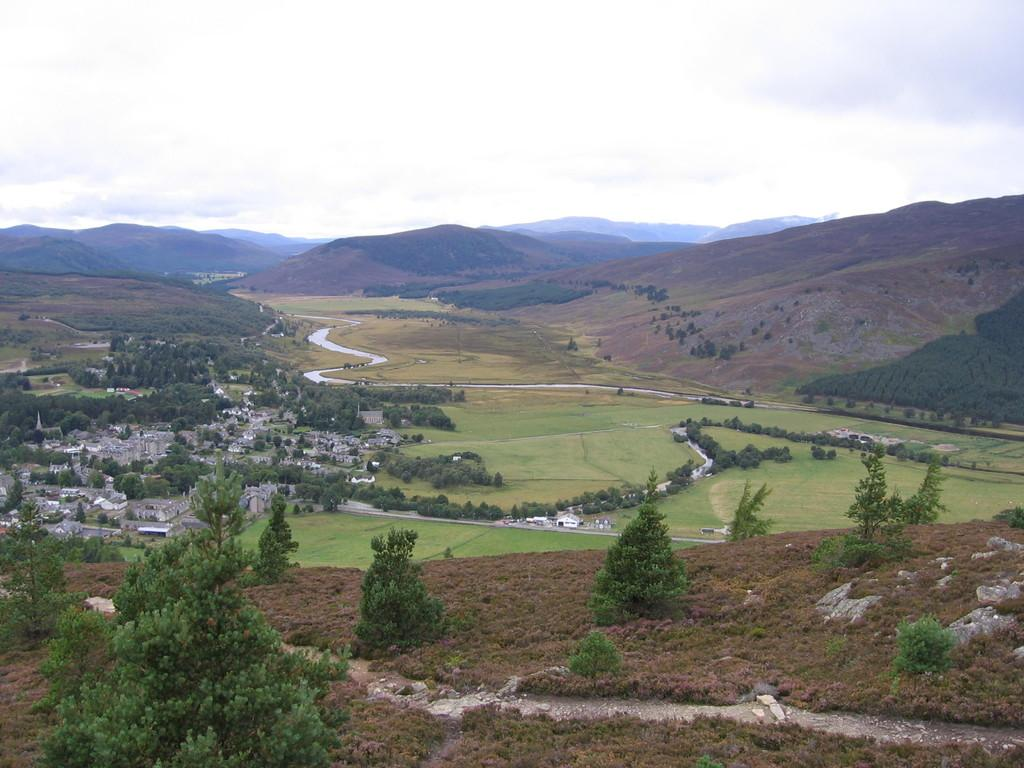What type of terrain is visible in the image? There is ground visible in the image, and there is grass present as well. What type of structures can be seen in the image? There are buildings in the image. What type of vegetation is present in the image? There are green trees in the image. What type of pathway is visible in the image? There is a road in the image. What can be seen in the background of the image? Mountains and the sky are visible in the background of the image. Where is the library located in the image? There is no library present in the image. What type of quilt is draped over the mountains in the image? There is no quilt present in the image; it is a natural landscape with mountains and the sky. 